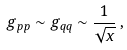<formula> <loc_0><loc_0><loc_500><loc_500>g _ { p p } \sim g _ { q q } \sim \frac { 1 } { \sqrt { x } } \, ,</formula> 